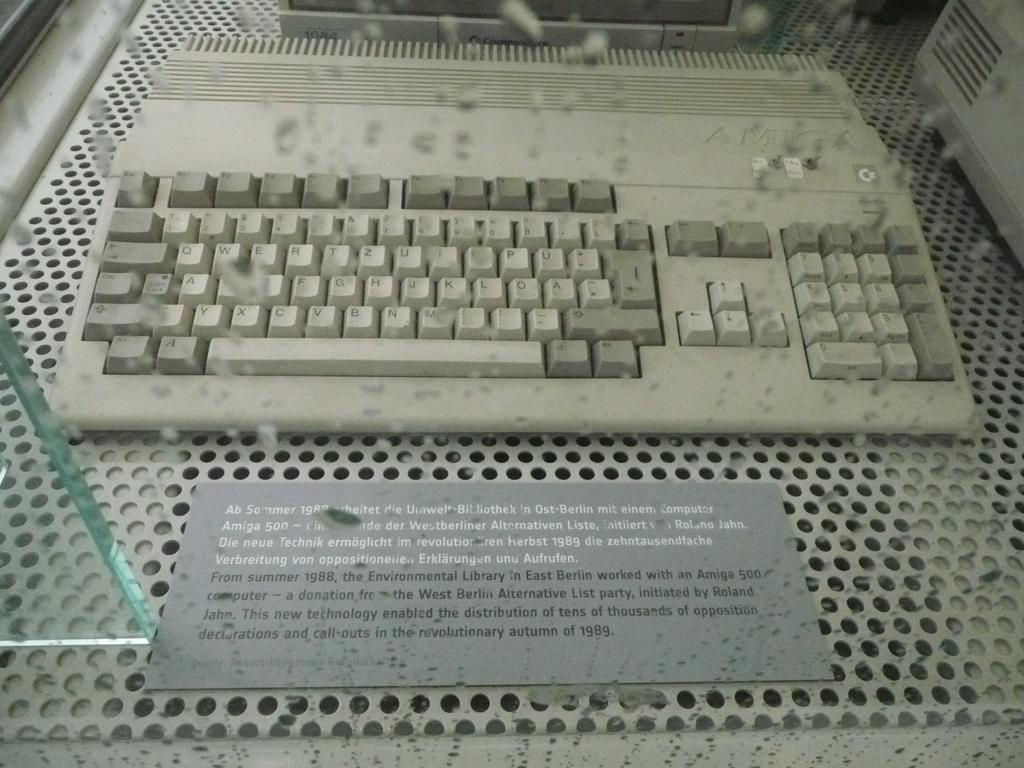<image>
Write a terse but informative summary of the picture. A keyboard sits behind a placard that begins with the words, "Ab Sommer 1988." 